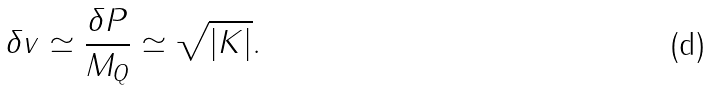Convert formula to latex. <formula><loc_0><loc_0><loc_500><loc_500>\delta v \simeq \frac { \delta P } { M _ { Q } } \simeq \sqrt { | K | } .</formula> 